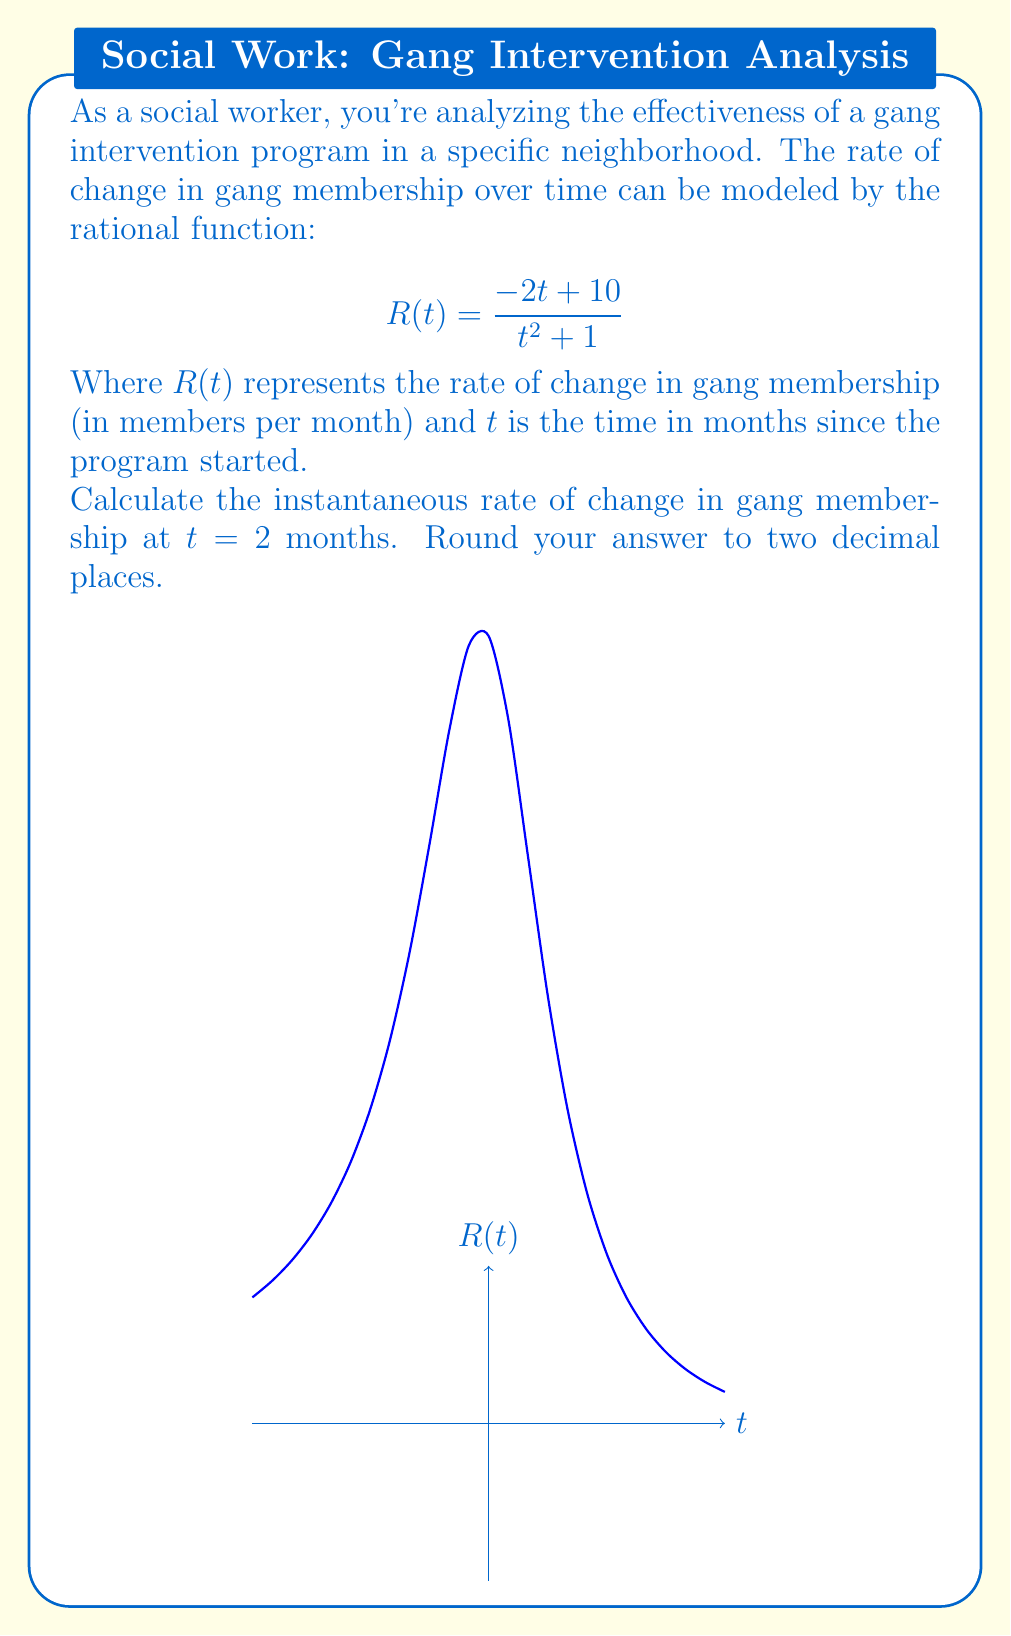Give your solution to this math problem. To find the instantaneous rate of change at $t = 2$, we need to evaluate $R(2)$:

1) Start with the given function:
   $$R(t) = \frac{-2t + 10}{t^2 + 1}$$

2) Substitute $t = 2$ into the function:
   $$R(2) = \frac{-2(2) + 10}{2^2 + 1}$$

3) Simplify the numerator:
   $$R(2) = \frac{-4 + 10}{2^2 + 1} = \frac{6}{2^2 + 1}$$

4) Simplify the denominator:
   $$R(2) = \frac{6}{4 + 1} = \frac{6}{5}$$

5) Divide and round to two decimal places:
   $$R(2) = 1.20$$

Therefore, the instantaneous rate of change in gang membership at 2 months is 1.20 members per month.
Answer: 1.20 members/month 